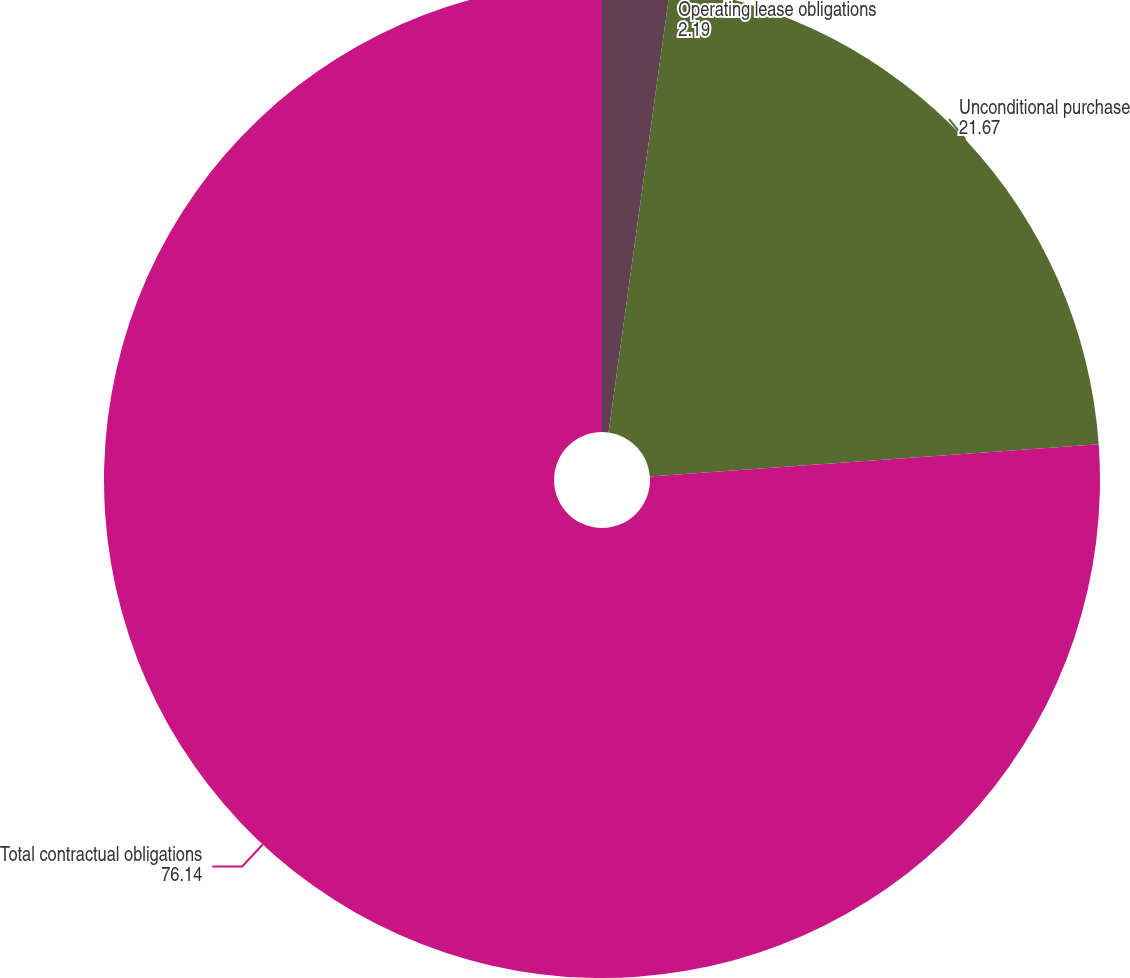<chart> <loc_0><loc_0><loc_500><loc_500><pie_chart><fcel>Operating lease obligations<fcel>Unconditional purchase<fcel>Total contractual obligations<nl><fcel>2.19%<fcel>21.67%<fcel>76.14%<nl></chart> 